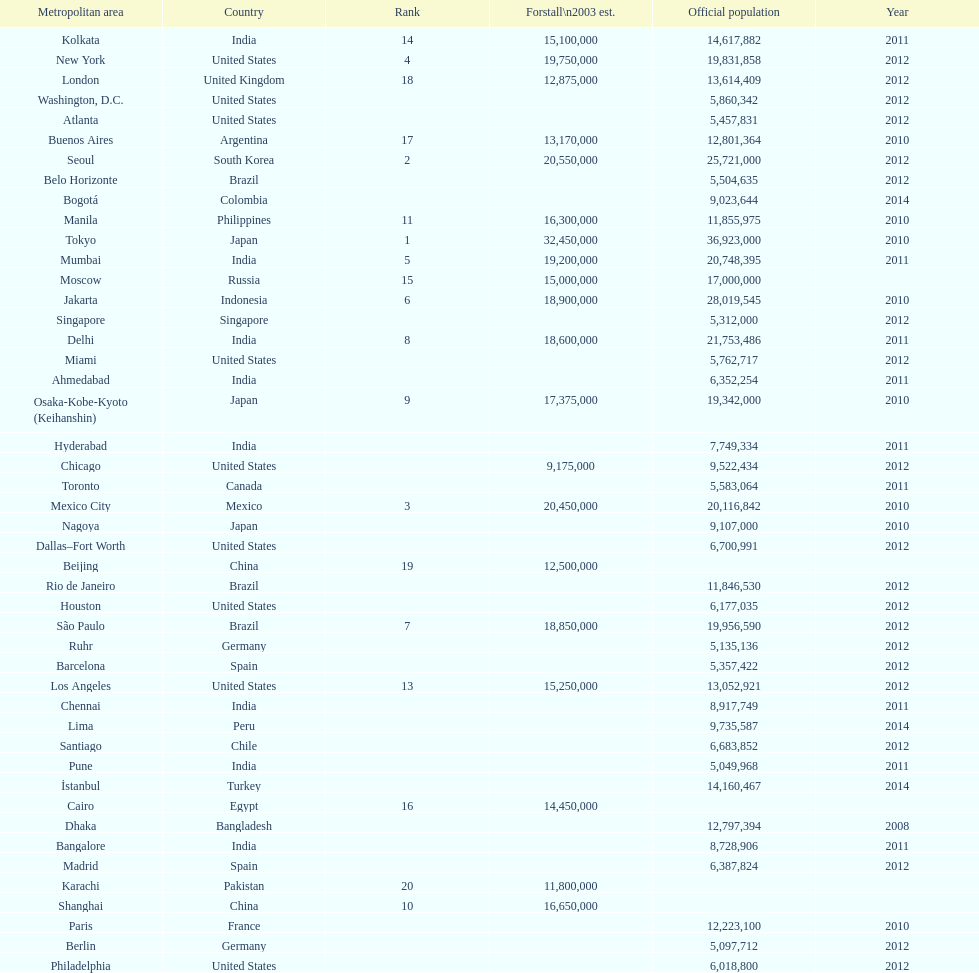Which areas had a population of more than 10,000,000 but less than 20,000,000? Buenos Aires, Dhaka, İstanbul, Kolkata, London, Los Angeles, Manila, Moscow, New York, Osaka-Kobe-Kyoto (Keihanshin), Paris, Rio de Janeiro, São Paulo. 